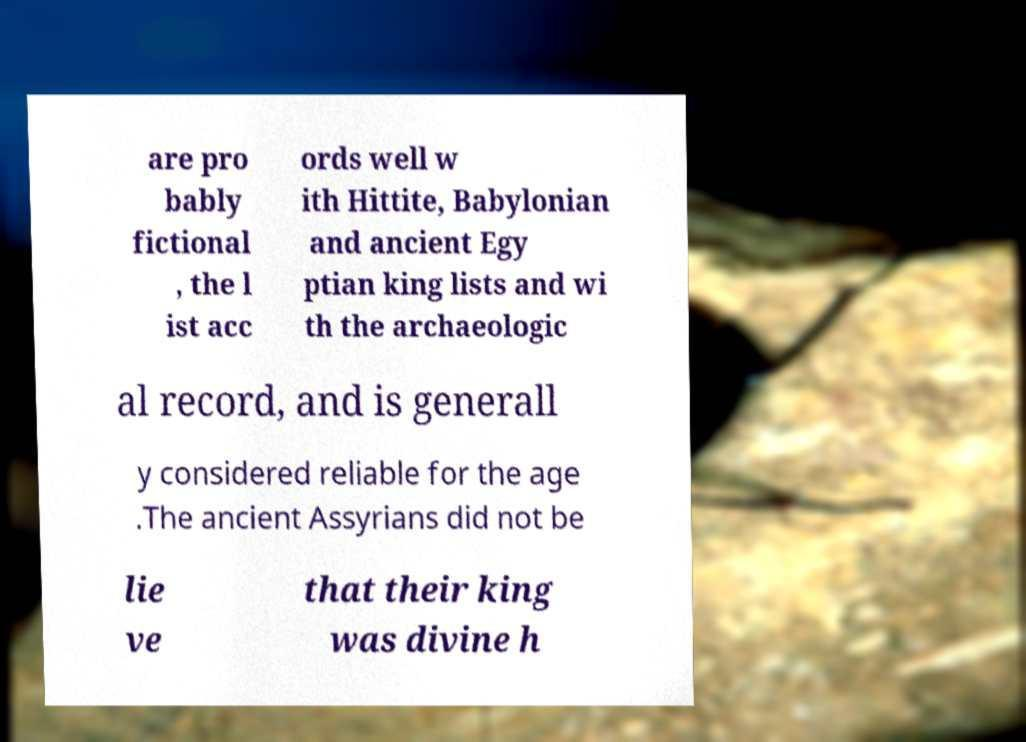What messages or text are displayed in this image? I need them in a readable, typed format. are pro bably fictional , the l ist acc ords well w ith Hittite, Babylonian and ancient Egy ptian king lists and wi th the archaeologic al record, and is generall y considered reliable for the age .The ancient Assyrians did not be lie ve that their king was divine h 